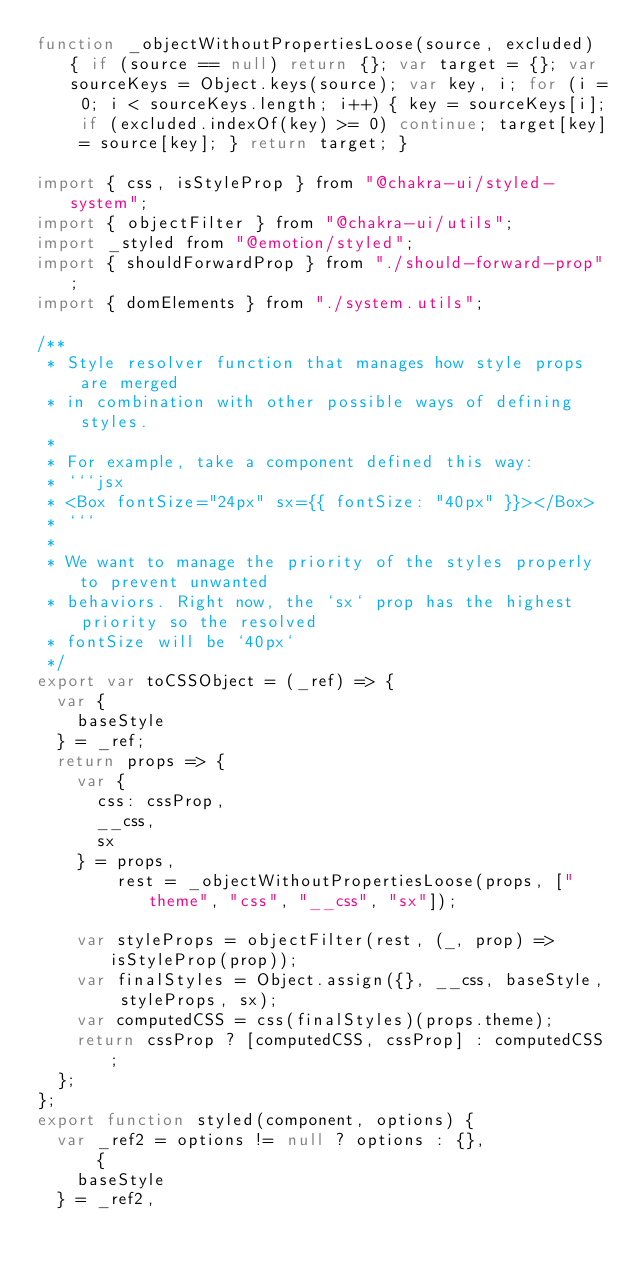<code> <loc_0><loc_0><loc_500><loc_500><_JavaScript_>function _objectWithoutPropertiesLoose(source, excluded) { if (source == null) return {}; var target = {}; var sourceKeys = Object.keys(source); var key, i; for (i = 0; i < sourceKeys.length; i++) { key = sourceKeys[i]; if (excluded.indexOf(key) >= 0) continue; target[key] = source[key]; } return target; }

import { css, isStyleProp } from "@chakra-ui/styled-system";
import { objectFilter } from "@chakra-ui/utils";
import _styled from "@emotion/styled";
import { shouldForwardProp } from "./should-forward-prop";
import { domElements } from "./system.utils";

/**
 * Style resolver function that manages how style props are merged
 * in combination with other possible ways of defining styles.
 *
 * For example, take a component defined this way:
 * ```jsx
 * <Box fontSize="24px" sx={{ fontSize: "40px" }}></Box>
 * ```
 *
 * We want to manage the priority of the styles properly to prevent unwanted
 * behaviors. Right now, the `sx` prop has the highest priority so the resolved
 * fontSize will be `40px`
 */
export var toCSSObject = (_ref) => {
  var {
    baseStyle
  } = _ref;
  return props => {
    var {
      css: cssProp,
      __css,
      sx
    } = props,
        rest = _objectWithoutPropertiesLoose(props, ["theme", "css", "__css", "sx"]);

    var styleProps = objectFilter(rest, (_, prop) => isStyleProp(prop));
    var finalStyles = Object.assign({}, __css, baseStyle, styleProps, sx);
    var computedCSS = css(finalStyles)(props.theme);
    return cssProp ? [computedCSS, cssProp] : computedCSS;
  };
};
export function styled(component, options) {
  var _ref2 = options != null ? options : {},
      {
    baseStyle
  } = _ref2,</code> 